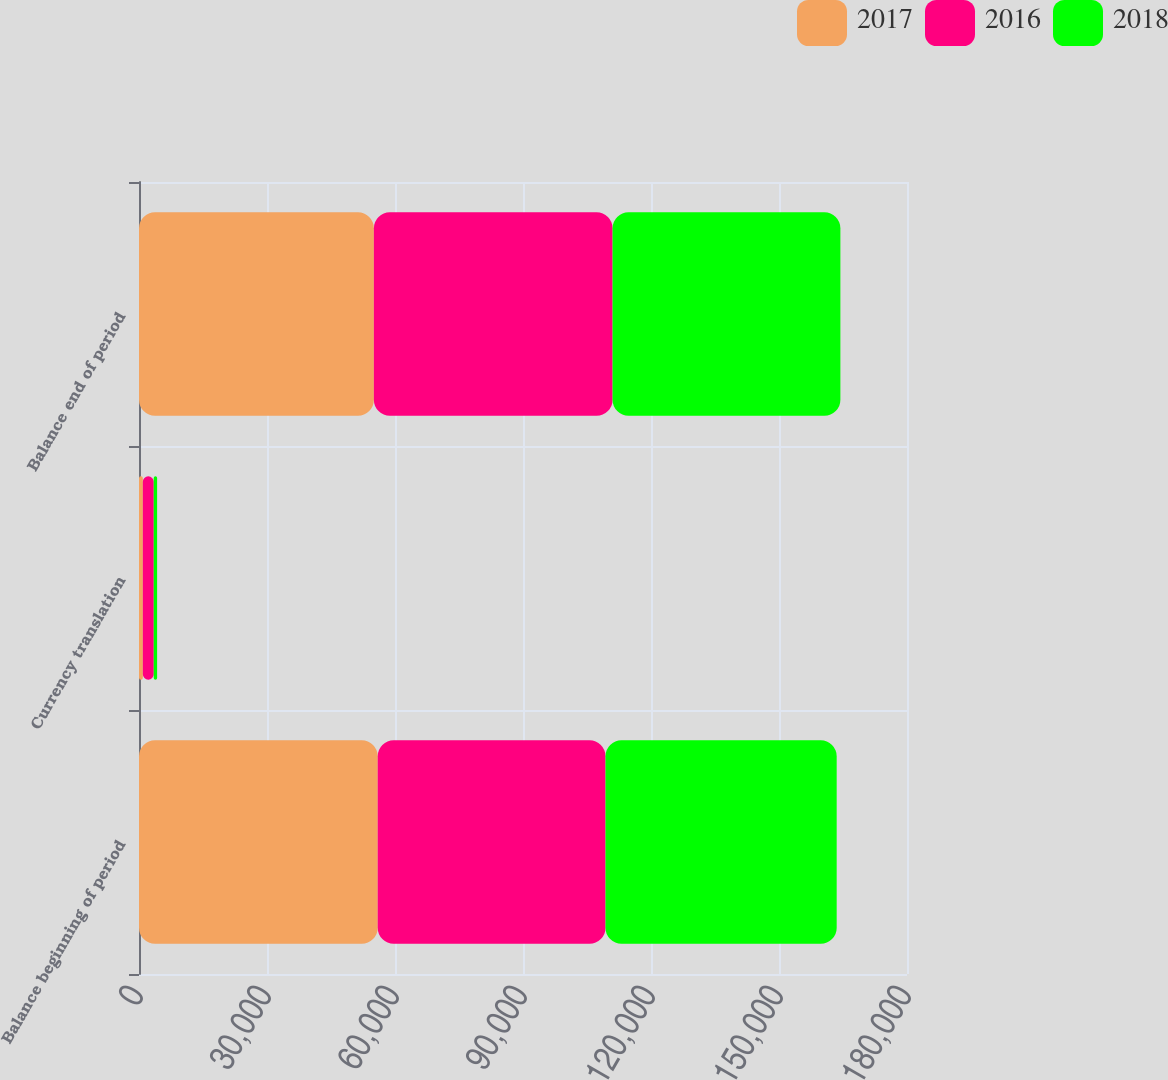Convert chart. <chart><loc_0><loc_0><loc_500><loc_500><stacked_bar_chart><ecel><fcel>Balance beginning of period<fcel>Currency translation<fcel>Balance end of period<nl><fcel>2017<fcel>55947<fcel>899<fcel>55048<nl><fcel>2016<fcel>53391<fcel>2556<fcel>55947<nl><fcel>2018<fcel>54182<fcel>791<fcel>53391<nl></chart> 